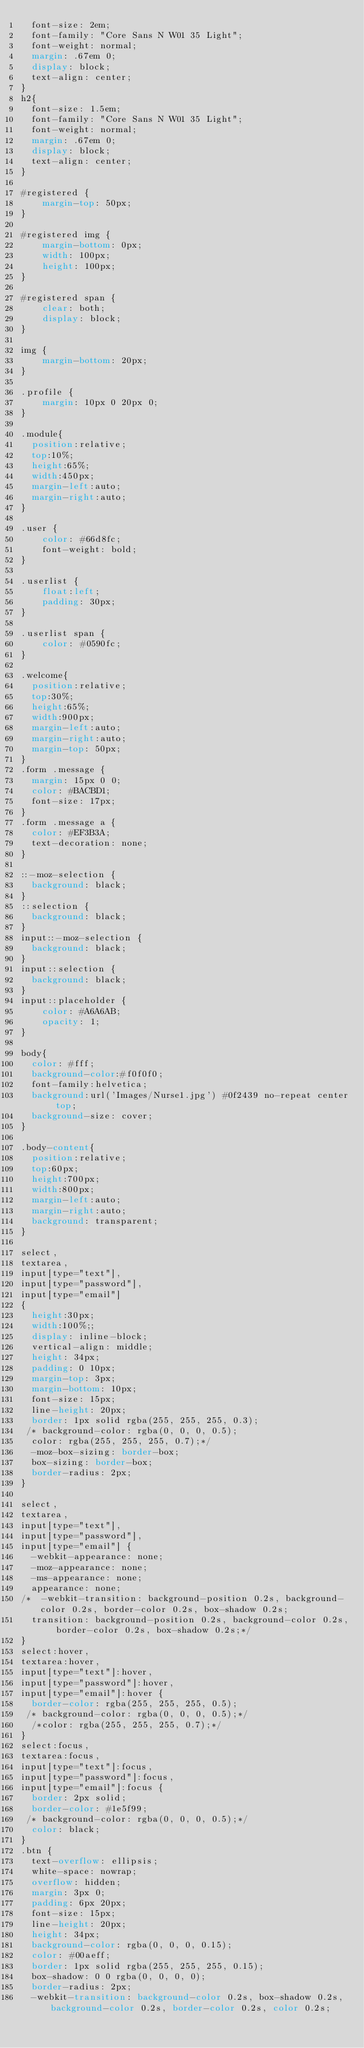<code> <loc_0><loc_0><loc_500><loc_500><_CSS_>  font-size: 2em;
  font-family: "Core Sans N W01 35 Light";
  font-weight: normal;
  margin: .67em 0;
  display: block;
  text-align: center;
}
h2{
  font-size: 1.5em;
  font-family: "Core Sans N W01 35 Light";
  font-weight: normal;
  margin: .67em 0;
  display: block;
  text-align: center;
}

#registered {
    margin-top: 50px;
}

#registered img {
    margin-bottom: 0px;
    width: 100px;
    height: 100px;
}

#registered span {
    clear: both;
    display: block;
}

img {
    margin-bottom: 20px;
}

.profile {
    margin: 10px 0 20px 0;
}

.module{
  position:relative;
  top:10%;    
  height:65%;
  width:450px;
  margin-left:auto;
  margin-right:auto;
}

.user {
    color: #66d8fc;
    font-weight: bold;
}

.userlist {
    float:left;
    padding: 30px;
}

.userlist span {
    color: #0590fc;
}

.welcome{
  position:relative;
  top:30%;    
  height:65%;
  width:900px;
  margin-left:auto;
  margin-right:auto;
  margin-top: 50px;
}
.form .message {
  margin: 15px 0 0;
  color: #BACBD1;
  font-size: 17px;
}
.form .message a {
  color: #EF3B3A;
  text-decoration: none;
}

::-moz-selection {
  background: black;
}
::selection {
  background: black;
}
input::-moz-selection {
  background: black;
}
input::selection {
  background: black;
}
input::placeholder { 
    color: #A6A6AB;
    opacity: 1; 
}

body{
  color: #fff;
  background-color:#f0f0f0;
  font-family:helvetica;
  background:url('Images/Nurse1.jpg') #0f2439 no-repeat center top;
  background-size: cover;
}

.body-content{
  position:relative;
  top:60px;
  height:700px;
  width:800px;
  margin-left:auto;
  margin-right:auto; 
  background: transparent;
}

select,
textarea,
input[type="text"],
input[type="password"],
input[type="email"]
{
  height:30px;
  width:100%;;
  display: inline-block;
  vertical-align: middle;
  height: 34px;
  padding: 0 10px;
  margin-top: 3px;
  margin-bottom: 10px;
  font-size: 15px;
  line-height: 20px;
  border: 1px solid rgba(255, 255, 255, 0.3);
 /* background-color: rgba(0, 0, 0, 0.5);
  color: rgba(255, 255, 255, 0.7);*/
  -moz-box-sizing: border-box;
  box-sizing: border-box;
  border-radius: 2px;
}

select,
textarea,
input[type="text"],
input[type="password"],
input[type="email"] {
  -webkit-appearance: none;
  -moz-appearance: none;
  -ms-appearance: none;
  appearance: none;
/*  -webkit-transition: background-position 0.2s, background-color 0.2s, border-color 0.2s, box-shadow 0.2s;
  transition: background-position 0.2s, background-color 0.2s, border-color 0.2s, box-shadow 0.2s;*/
}
select:hover,
textarea:hover,
input[type="text"]:hover,
input[type="password"]:hover,
input[type="email"]:hover {
  border-color: rgba(255, 255, 255, 0.5);
 /* background-color: rgba(0, 0, 0, 0.5);*/
  /*color: rgba(255, 255, 255, 0.7);*/
}
select:focus,
textarea:focus,
input[type="text"]:focus,
input[type="password"]:focus,
input[type="email"]:focus {
  border: 2px solid;
  border-color: #1e5f99;
 /* background-color: rgba(0, 0, 0, 0.5);*/
  color: black;
}
.btn {
  text-overflow: ellipsis;
  white-space: nowrap;
  overflow: hidden;
  margin: 3px 0;
  padding: 6px 20px;
  font-size: 15px;
  line-height: 20px;
  height: 34px;
  background-color: rgba(0, 0, 0, 0.15);
  color: #00aeff;
  border: 1px solid rgba(255, 255, 255, 0.15);
  box-shadow: 0 0 rgba(0, 0, 0, 0);
  border-radius: 2px;
  -webkit-transition: background-color 0.2s, box-shadow 0.2s, background-color 0.2s, border-color 0.2s, color 0.2s;</code> 